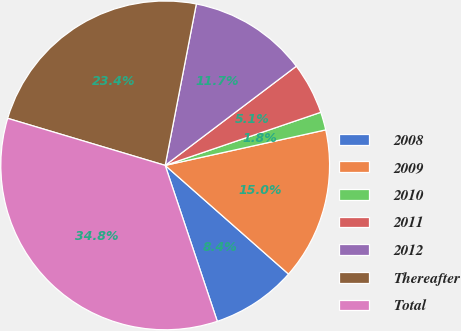<chart> <loc_0><loc_0><loc_500><loc_500><pie_chart><fcel>2008<fcel>2009<fcel>2010<fcel>2011<fcel>2012<fcel>Thereafter<fcel>Total<nl><fcel>8.37%<fcel>14.96%<fcel>1.77%<fcel>5.07%<fcel>11.66%<fcel>23.41%<fcel>34.75%<nl></chart> 